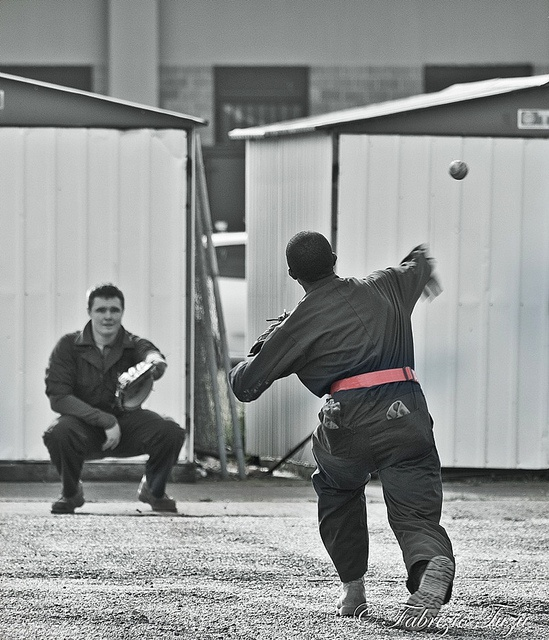Describe the objects in this image and their specific colors. I can see people in gray, black, darkgray, and lightgray tones, people in gray, black, darkgray, and lightgray tones, car in gray, lightgray, and darkgray tones, baseball glove in gray, black, lightgray, and darkgray tones, and baseball bat in gray, black, and darkgray tones in this image. 